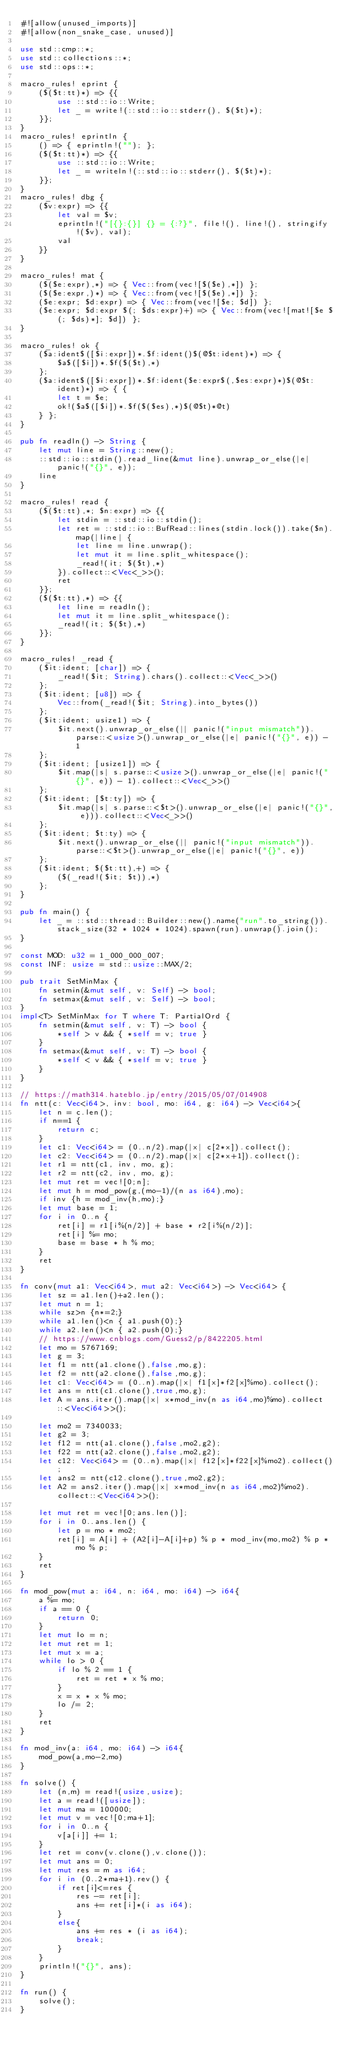<code> <loc_0><loc_0><loc_500><loc_500><_Rust_>#![allow(unused_imports)]
#![allow(non_snake_case, unused)]

use std::cmp::*;
use std::collections::*;
use std::ops::*;

macro_rules! eprint {
	($($t:tt)*) => {{
		use ::std::io::Write;
		let _ = write!(::std::io::stderr(), $($t)*);
	}};
}
macro_rules! eprintln {
	() => { eprintln!(""); };
	($($t:tt)*) => {{
		use ::std::io::Write;
		let _ = writeln!(::std::io::stderr(), $($t)*);
	}};
}
macro_rules! dbg {
	($v:expr) => {{
		let val = $v;
		eprintln!("[{}:{}] {} = {:?}", file!(), line!(), stringify!($v), val);
		val
	}}
}

macro_rules! mat {
	($($e:expr),*) => { Vec::from(vec![$($e),*]) };
	($($e:expr,)*) => { Vec::from(vec![$($e),*]) };
	($e:expr; $d:expr) => { Vec::from(vec![$e; $d]) };
	($e:expr; $d:expr $(; $ds:expr)+) => { Vec::from(vec![mat![$e $(; $ds)*]; $d]) };
}

macro_rules! ok {
	($a:ident$([$i:expr])*.$f:ident()$(@$t:ident)*) => {
		$a$([$i])*.$f($($t),*)
	};
	($a:ident$([$i:expr])*.$f:ident($e:expr$(,$es:expr)*)$(@$t:ident)*) => { {
		let t = $e;
		ok!($a$([$i])*.$f($($es),*)$(@$t)*@t)
	} };
}

pub fn readln() -> String {
	let mut line = String::new();
	::std::io::stdin().read_line(&mut line).unwrap_or_else(|e| panic!("{}", e));
	line
}

macro_rules! read {
	($($t:tt),*; $n:expr) => {{
		let stdin = ::std::io::stdin();
		let ret = ::std::io::BufRead::lines(stdin.lock()).take($n).map(|line| {
			let line = line.unwrap();
			let mut it = line.split_whitespace();
			_read!(it; $($t),*)
		}).collect::<Vec<_>>();
		ret
	}};
	($($t:tt),*) => {{
		let line = readln();
		let mut it = line.split_whitespace();
		_read!(it; $($t),*)
	}};
}

macro_rules! _read {
	($it:ident; [char]) => {
		_read!($it; String).chars().collect::<Vec<_>>()
	};
	($it:ident; [u8]) => {
		Vec::from(_read!($it; String).into_bytes())
	};
	($it:ident; usize1) => {
		$it.next().unwrap_or_else(|| panic!("input mismatch")).parse::<usize>().unwrap_or_else(|e| panic!("{}", e)) - 1
	};
	($it:ident; [usize1]) => {
		$it.map(|s| s.parse::<usize>().unwrap_or_else(|e| panic!("{}", e)) - 1).collect::<Vec<_>>()
	};
	($it:ident; [$t:ty]) => {
		$it.map(|s| s.parse::<$t>().unwrap_or_else(|e| panic!("{}", e))).collect::<Vec<_>>()
	};
	($it:ident; $t:ty) => {
		$it.next().unwrap_or_else(|| panic!("input mismatch")).parse::<$t>().unwrap_or_else(|e| panic!("{}", e))
	};
	($it:ident; $($t:tt),+) => {
		($(_read!($it; $t)),*)
	};
}

pub fn main() {
	let _ = ::std::thread::Builder::new().name("run".to_string()).stack_size(32 * 1024 * 1024).spawn(run).unwrap().join();
}

const MOD: u32 = 1_000_000_007;
const INF: usize = std::usize::MAX/2;

pub trait SetMinMax {
	fn setmin(&mut self, v: Self) -> bool;
	fn setmax(&mut self, v: Self) -> bool;
}
impl<T> SetMinMax for T where T: PartialOrd {
	fn setmin(&mut self, v: T) -> bool {
		*self > v && { *self = v; true }
	}
	fn setmax(&mut self, v: T) -> bool {
		*self < v && { *self = v; true }
	}
}

// https://math314.hateblo.jp/entry/2015/05/07/014908
fn ntt(c: Vec<i64>, inv: bool, mo: i64, g: i64) -> Vec<i64>{
    let n = c.len();
    if n==1 {
        return c;
    }
    let c1: Vec<i64> = (0..n/2).map(|x| c[2*x]).collect();
	let c2: Vec<i64> = (0..n/2).map(|x| c[2*x+1]).collect();
	let r1 = ntt(c1, inv, mo, g);
    let r2 = ntt(c2, inv, mo, g);
    let mut ret = vec![0;n];
	let mut h = mod_pow(g,(mo-1)/(n as i64),mo);
	if inv {h = mod_inv(h,mo);}
	let mut base = 1;
    for i in 0..n {
		ret[i] = r1[i%(n/2)] + base * r2[i%(n/2)];
		ret[i] %= mo;
		base = base * h % mo;
    }
    ret
}

fn conv(mut a1: Vec<i64>, mut a2: Vec<i64>) -> Vec<i64> {
    let sz = a1.len()+a2.len();
    let mut n = 1;
	while sz>n {n*=2;}
	while a1.len()<n { a1.push(0);}
	while a2.len()<n { a2.push(0);}
	// https://www.cnblogs.com/Guess2/p/8422205.html
	let mo = 5767169;
	let g = 3;
	let f1 = ntt(a1.clone(),false,mo,g);
	let f2 = ntt(a2.clone(),false,mo,g);
	let c1: Vec<i64> = (0..n).map(|x| f1[x]*f2[x]%mo).collect();
	let ans = ntt(c1.clone(),true,mo,g);
	let A = ans.iter().map(|x| x*mod_inv(n as i64,mo)%mo).collect::<Vec<i64>>();

	let mo2 = 7340033;
	let g2 = 3;
	let f12 = ntt(a1.clone(),false,mo2,g2);
	let f22 = ntt(a2.clone(),false,mo2,g2);
	let c12: Vec<i64> = (0..n).map(|x| f12[x]*f22[x]%mo2).collect();
	let ans2 = ntt(c12.clone(),true,mo2,g2);
	let A2 = ans2.iter().map(|x| x*mod_inv(n as i64,mo2)%mo2).collect::<Vec<i64>>();

	let mut ret = vec![0;ans.len()];
	for i in 0..ans.len() {
		let p = mo * mo2;
		ret[i] = A[i] + (A2[i]-A[i]+p) % p * mod_inv(mo,mo2) % p * mo % p;
	}
	ret
}

fn mod_pow(mut a: i64, n: i64, mo: i64) -> i64{
	a %= mo;
	if a == 0 {
		return 0;
	}
	let mut lo = n;
	let mut ret = 1;
	let mut x = a;
	while lo > 0 {
		if lo % 2 == 1 {
			ret = ret * x % mo;
		}
		x = x * x % mo;
		lo /= 2;
	}
	ret
}

fn mod_inv(a: i64, mo: i64) -> i64{
	mod_pow(a,mo-2,mo)
}

fn solve() {
	let (n,m) = read!(usize,usize);
	let a = read!([usize]);
	let mut ma = 100000;
	let mut v = vec![0;ma+1];
	for i in 0..n {
		v[a[i]] += 1;
	}
	let ret = conv(v.clone(),v.clone());
	let mut ans = 0;
	let mut res = m as i64;
	for i in (0..2*ma+1).rev() {
		if ret[i]<=res {
			res -= ret[i];
			ans += ret[i]*(i as i64);
		}
		else{
			ans += res * (i as i64);
			break;
		}
	}
	println!("{}", ans);
}

fn run() {
    solve();
}</code> 